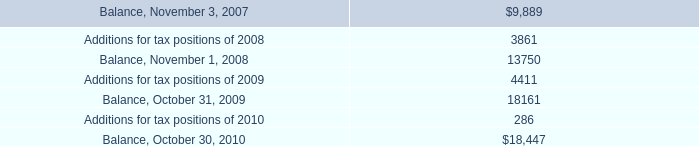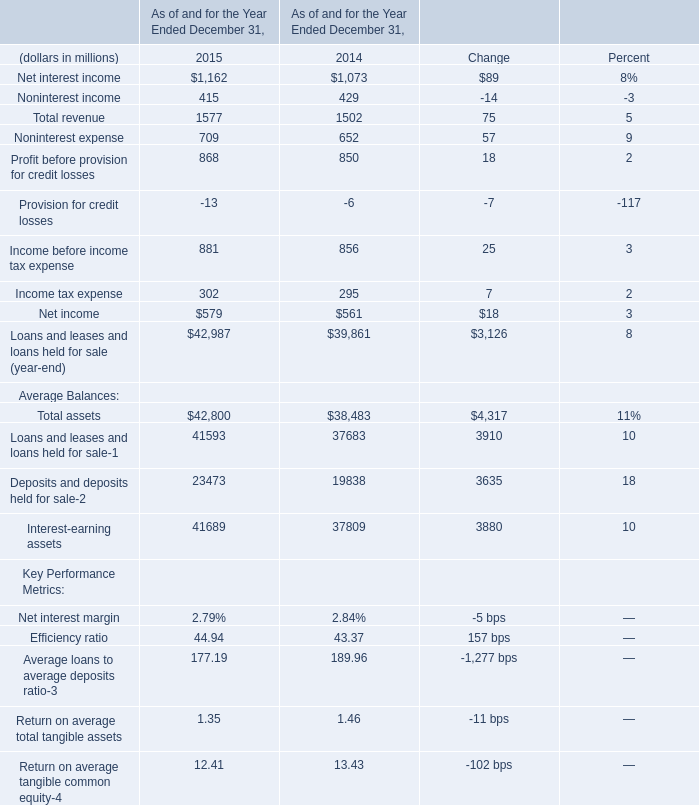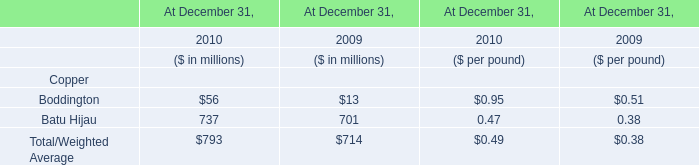In the year with lowest amount of Noninterest expense, what's the increasing rate of Total revenue? 
Computations: (75 / 1502)
Answer: 0.04993. 